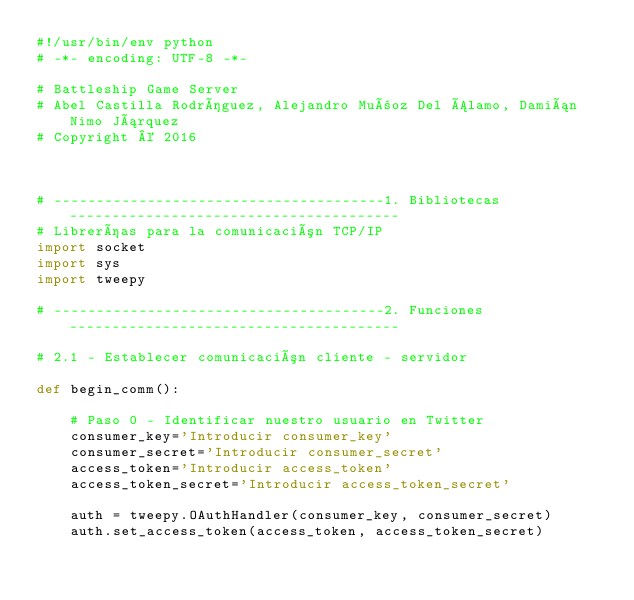<code> <loc_0><loc_0><loc_500><loc_500><_Python_>#!/usr/bin/env python
# -*- encoding: UTF-8 -*-

# Battleship Game Server
# Abel Castilla Rodríguez, Alejandro Muñoz Del Álamo, Damián Nimo Járquez
# Copyright © 2016



# ---------------------------------------1. Bibliotecas---------------------------------------
# Librerías para la comunicación TCP/IP
import socket 
import sys
import tweepy

# ---------------------------------------2. Funciones---------------------------------------

# 2.1 - Establecer comunicación cliente - servidor

def begin_comm():	

	# Paso 0 - Identificar nuestro usuario en Twitter
	consumer_key='Introducir consumer_key'
	consumer_secret='Introducir consumer_secret'
	access_token='Introducir access_token'
	access_token_secret='Introducir access_token_secret'

	auth = tweepy.OAuthHandler(consumer_key, consumer_secret)
	auth.set_access_token(access_token, access_token_secret)
</code> 